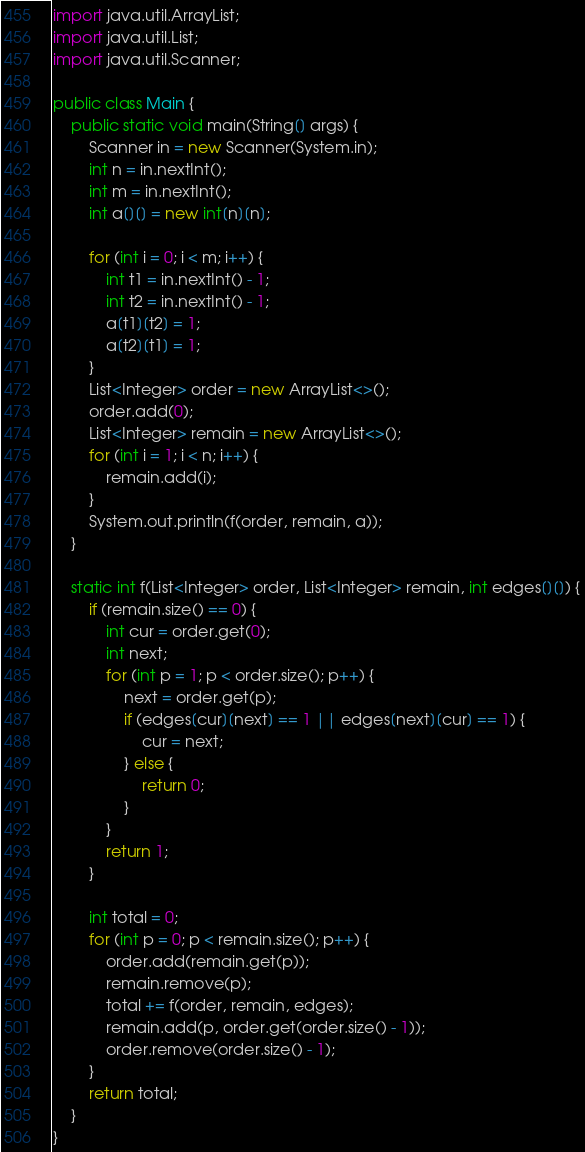<code> <loc_0><loc_0><loc_500><loc_500><_Java_>import java.util.ArrayList;
import java.util.List;
import java.util.Scanner;

public class Main {
    public static void main(String[] args) {
        Scanner in = new Scanner(System.in);
        int n = in.nextInt();
        int m = in.nextInt();
        int a[][] = new int[n][n];

        for (int i = 0; i < m; i++) {
            int t1 = in.nextInt() - 1;
            int t2 = in.nextInt() - 1;
            a[t1][t2] = 1;
            a[t2][t1] = 1;
        }
        List<Integer> order = new ArrayList<>();
        order.add(0);
        List<Integer> remain = new ArrayList<>();
        for (int i = 1; i < n; i++) {
            remain.add(i);
        }
        System.out.println(f(order, remain, a));
    }

    static int f(List<Integer> order, List<Integer> remain, int edges[][]) {
        if (remain.size() == 0) {
            int cur = order.get(0);
            int next;
            for (int p = 1; p < order.size(); p++) {
                next = order.get(p);
                if (edges[cur][next] == 1 || edges[next][cur] == 1) {
                    cur = next; 
                } else {
                    return 0;
                }
            }
            return 1;
        }

        int total = 0;
        for (int p = 0; p < remain.size(); p++) {
            order.add(remain.get(p));
            remain.remove(p);
            total += f(order, remain, edges);
            remain.add(p, order.get(order.size() - 1));
            order.remove(order.size() - 1);
        }
        return total;
    }
}</code> 